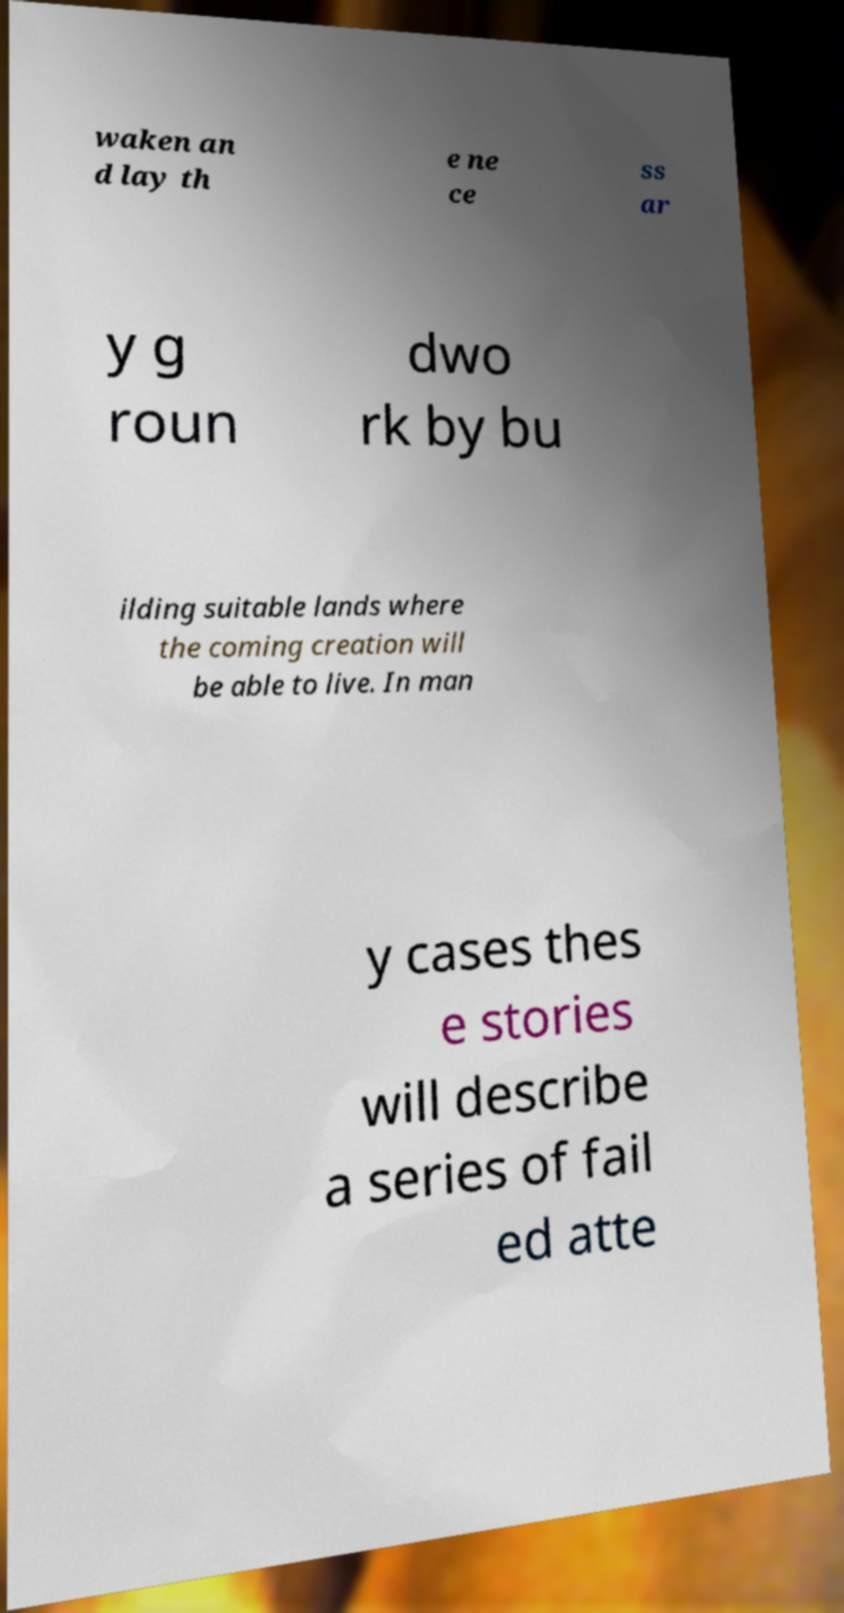Can you accurately transcribe the text from the provided image for me? waken an d lay th e ne ce ss ar y g roun dwo rk by bu ilding suitable lands where the coming creation will be able to live. In man y cases thes e stories will describe a series of fail ed atte 